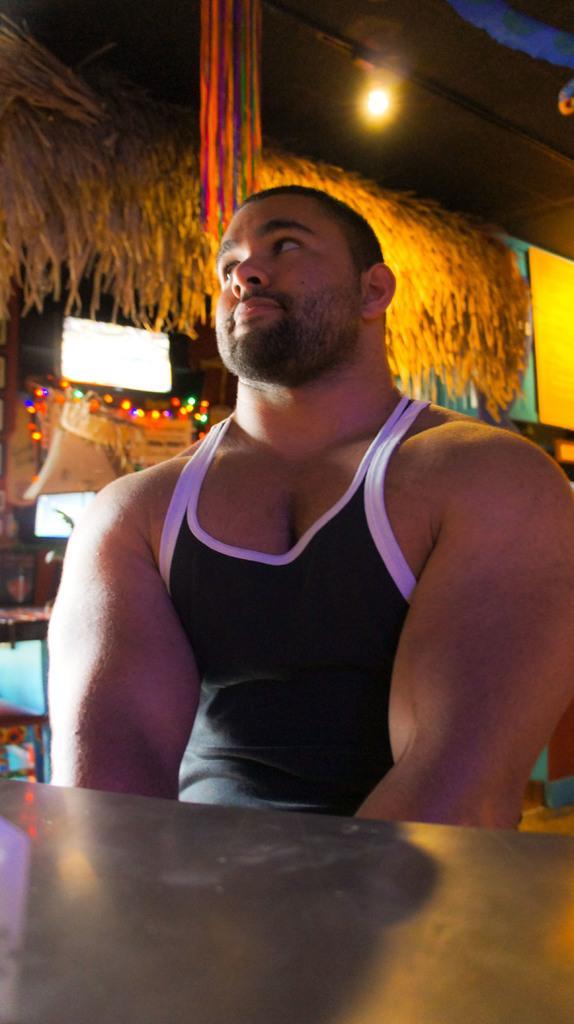Could you give a brief overview of what you see in this image? In this image there is a person near a table, there are lights, television, hut and some objects. 